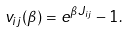Convert formula to latex. <formula><loc_0><loc_0><loc_500><loc_500>v _ { i j } ( \beta ) = e ^ { \beta J _ { i j } } - 1 .</formula> 